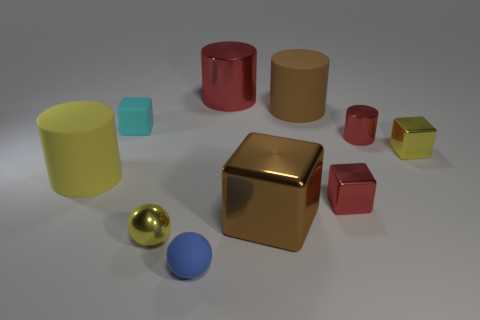Subtract 1 blocks. How many blocks are left? 3 Subtract all spheres. How many objects are left? 8 Subtract 0 gray cylinders. How many objects are left? 10 Subtract all green cubes. Subtract all brown metallic cubes. How many objects are left? 9 Add 7 tiny red blocks. How many tiny red blocks are left? 8 Add 9 large gray shiny things. How many large gray shiny things exist? 9 